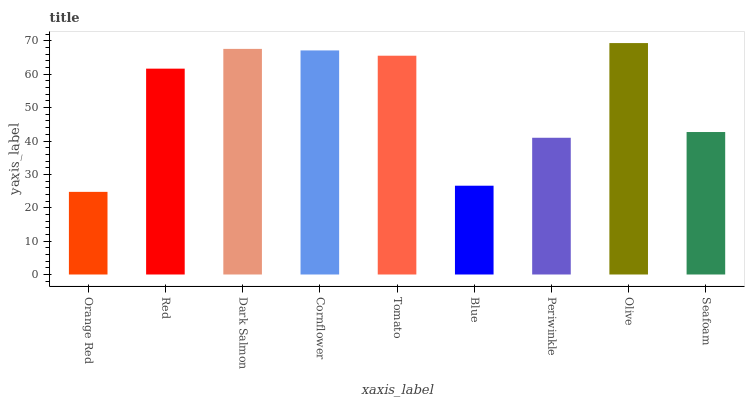Is Orange Red the minimum?
Answer yes or no. Yes. Is Olive the maximum?
Answer yes or no. Yes. Is Red the minimum?
Answer yes or no. No. Is Red the maximum?
Answer yes or no. No. Is Red greater than Orange Red?
Answer yes or no. Yes. Is Orange Red less than Red?
Answer yes or no. Yes. Is Orange Red greater than Red?
Answer yes or no. No. Is Red less than Orange Red?
Answer yes or no. No. Is Red the high median?
Answer yes or no. Yes. Is Red the low median?
Answer yes or no. Yes. Is Tomato the high median?
Answer yes or no. No. Is Blue the low median?
Answer yes or no. No. 